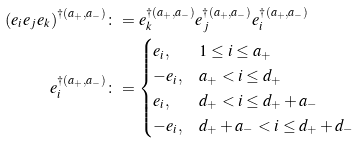<formula> <loc_0><loc_0><loc_500><loc_500>\left ( e _ { i } e _ { j } e _ { k } \right ) ^ { \dag ( a _ { + } , a _ { - } ) } & \colon = e _ { k } ^ { \dag ( a _ { + } , a _ { - } ) } e _ { j } ^ { \dag ( a _ { + } , a _ { - } ) } e _ { i } ^ { \dag ( a _ { + } , a _ { - } ) } \\ e _ { i } ^ { \dag ( a _ { + } , a _ { - } ) } & \colon = \begin{cases} e _ { i } , & 1 \leq i \leq a _ { + } \\ - e _ { i } , & a _ { + } < i \leq d _ { + } \\ e _ { i } , & d _ { + } < i \leq d _ { + } + a _ { - } \\ - e _ { i } , & d _ { + } + a _ { - } < i \leq d _ { + } + d _ { - } \end{cases}</formula> 